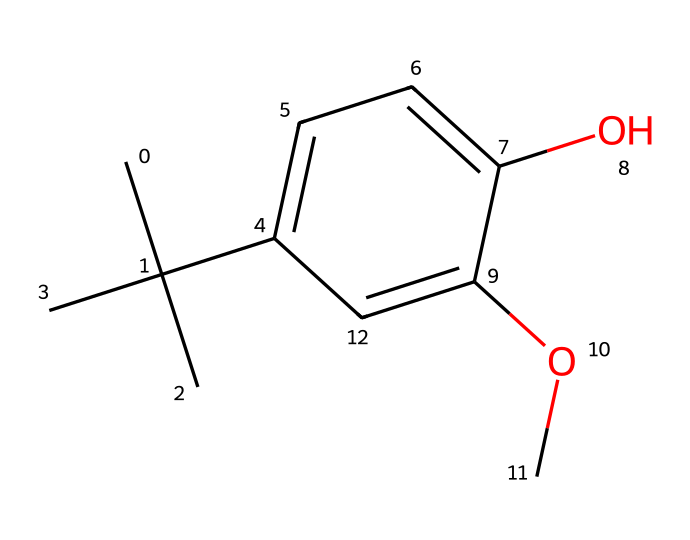What is the total number of carbon atoms in butylated hydroxyanisole (BHA)? By analyzing the SMILES, I can count the carbon (C) atoms present in the structure. The structure shows 11 carbon atoms.
Answer: 11 How many oxygen atoms are present in this chemical? In the SMILES representation, I identify the oxygen (O) atoms. There are 2 oxygen atoms in the structure.
Answer: 2 What functional groups are indicated in the chemical structure of BHA? Reviewing the SMILES, I see that there is a hydroxyl group (-OH) and a methoxy group (-OCH3), which are the functional groups present in BHA.
Answer: hydroxyl and methoxy What type of organic compound is butylated hydroxyanisole? The visual representation indicates that BHA contains an aromatic ring and alkyl substituents, categorizing it as a phenolic compound.
Answer: phenolic Why is BHA considered a preservative? BHA contains phenolic structures that can scavenge free radicals, thus preventing the oxidation of food products, which is the key reason it acts as a preservative.
Answer: prevents oxidation Which part of the chemical structure contributes to its antioxidant properties? The presence of the hydroxyl group (-OH) on the aromatic ring is crucial as it can donate hydrogen atoms, which helps in neutralizing free radicals, contributing to its antioxidant properties.
Answer: hydroxyl group 